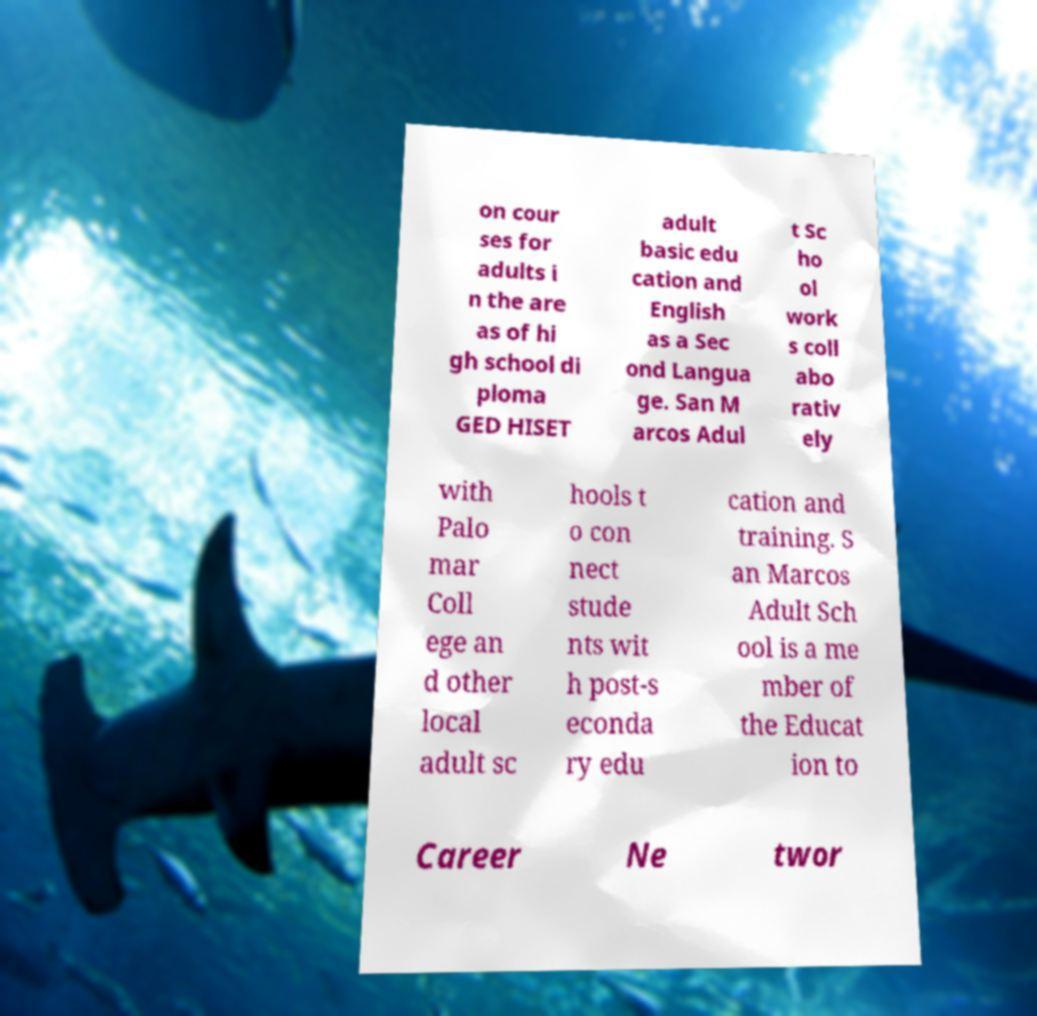Can you read and provide the text displayed in the image?This photo seems to have some interesting text. Can you extract and type it out for me? on cour ses for adults i n the are as of hi gh school di ploma GED HISET adult basic edu cation and English as a Sec ond Langua ge. San M arcos Adul t Sc ho ol work s coll abo rativ ely with Palo mar Coll ege an d other local adult sc hools t o con nect stude nts wit h post-s econda ry edu cation and training. S an Marcos Adult Sch ool is a me mber of the Educat ion to Career Ne twor 